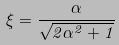Convert formula to latex. <formula><loc_0><loc_0><loc_500><loc_500>\xi = \frac { \alpha } { \sqrt { 2 \alpha ^ { 2 } + 1 } }</formula> 